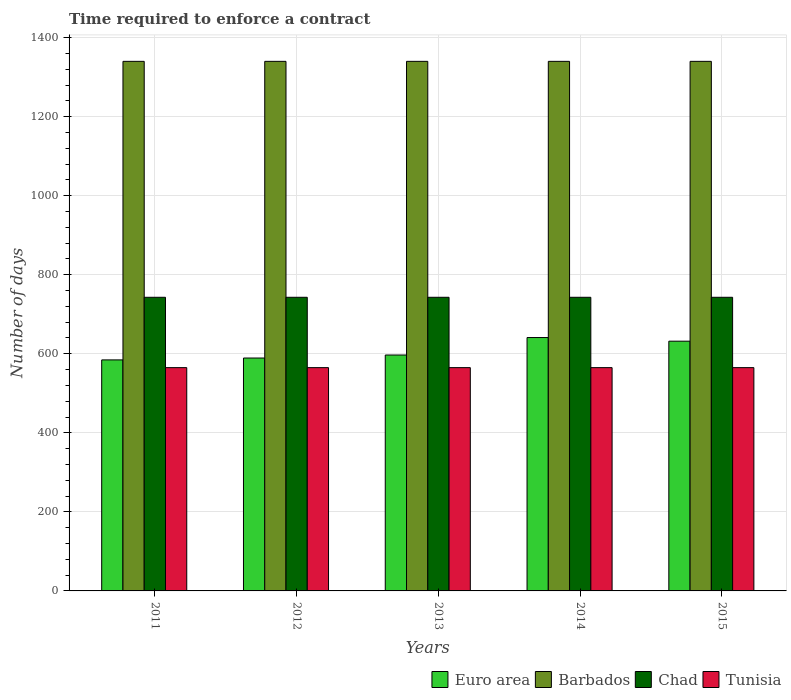How many different coloured bars are there?
Make the answer very short. 4. Are the number of bars per tick equal to the number of legend labels?
Your answer should be compact. Yes. What is the label of the 5th group of bars from the left?
Your answer should be very brief. 2015. What is the number of days required to enforce a contract in Tunisia in 2014?
Keep it short and to the point. 565. Across all years, what is the maximum number of days required to enforce a contract in Barbados?
Offer a terse response. 1340. Across all years, what is the minimum number of days required to enforce a contract in Tunisia?
Your answer should be compact. 565. What is the total number of days required to enforce a contract in Chad in the graph?
Offer a very short reply. 3715. What is the difference between the number of days required to enforce a contract in Barbados in 2015 and the number of days required to enforce a contract in Euro area in 2013?
Ensure brevity in your answer.  743.05. What is the average number of days required to enforce a contract in Chad per year?
Offer a terse response. 743. In the year 2013, what is the difference between the number of days required to enforce a contract in Tunisia and number of days required to enforce a contract in Barbados?
Give a very brief answer. -775. What is the ratio of the number of days required to enforce a contract in Euro area in 2013 to that in 2014?
Your answer should be very brief. 0.93. What is the difference between the highest and the lowest number of days required to enforce a contract in Chad?
Provide a succinct answer. 0. Is it the case that in every year, the sum of the number of days required to enforce a contract in Tunisia and number of days required to enforce a contract in Barbados is greater than the sum of number of days required to enforce a contract in Chad and number of days required to enforce a contract in Euro area?
Provide a short and direct response. No. What does the 2nd bar from the left in 2011 represents?
Provide a succinct answer. Barbados. What does the 2nd bar from the right in 2014 represents?
Ensure brevity in your answer.  Chad. Is it the case that in every year, the sum of the number of days required to enforce a contract in Tunisia and number of days required to enforce a contract in Chad is greater than the number of days required to enforce a contract in Euro area?
Provide a succinct answer. Yes. How many bars are there?
Your answer should be very brief. 20. Are all the bars in the graph horizontal?
Keep it short and to the point. No. What is the difference between two consecutive major ticks on the Y-axis?
Your answer should be very brief. 200. Does the graph contain any zero values?
Keep it short and to the point. No. Does the graph contain grids?
Ensure brevity in your answer.  Yes. How many legend labels are there?
Keep it short and to the point. 4. How are the legend labels stacked?
Give a very brief answer. Horizontal. What is the title of the graph?
Your answer should be very brief. Time required to enforce a contract. Does "Guinea-Bissau" appear as one of the legend labels in the graph?
Keep it short and to the point. No. What is the label or title of the Y-axis?
Give a very brief answer. Number of days. What is the Number of days of Euro area in 2011?
Ensure brevity in your answer.  584.58. What is the Number of days of Barbados in 2011?
Your answer should be compact. 1340. What is the Number of days of Chad in 2011?
Make the answer very short. 743. What is the Number of days in Tunisia in 2011?
Your answer should be very brief. 565. What is the Number of days in Euro area in 2012?
Ensure brevity in your answer.  589.32. What is the Number of days in Barbados in 2012?
Give a very brief answer. 1340. What is the Number of days in Chad in 2012?
Make the answer very short. 743. What is the Number of days in Tunisia in 2012?
Give a very brief answer. 565. What is the Number of days in Euro area in 2013?
Your response must be concise. 596.95. What is the Number of days in Barbados in 2013?
Your answer should be very brief. 1340. What is the Number of days in Chad in 2013?
Make the answer very short. 743. What is the Number of days of Tunisia in 2013?
Make the answer very short. 565. What is the Number of days of Euro area in 2014?
Make the answer very short. 641.16. What is the Number of days in Barbados in 2014?
Make the answer very short. 1340. What is the Number of days in Chad in 2014?
Keep it short and to the point. 743. What is the Number of days in Tunisia in 2014?
Your answer should be compact. 565. What is the Number of days in Euro area in 2015?
Make the answer very short. 631.95. What is the Number of days of Barbados in 2015?
Give a very brief answer. 1340. What is the Number of days in Chad in 2015?
Your answer should be compact. 743. What is the Number of days of Tunisia in 2015?
Your answer should be compact. 565. Across all years, what is the maximum Number of days in Euro area?
Give a very brief answer. 641.16. Across all years, what is the maximum Number of days of Barbados?
Offer a terse response. 1340. Across all years, what is the maximum Number of days in Chad?
Provide a short and direct response. 743. Across all years, what is the maximum Number of days of Tunisia?
Your response must be concise. 565. Across all years, what is the minimum Number of days in Euro area?
Offer a terse response. 584.58. Across all years, what is the minimum Number of days of Barbados?
Provide a short and direct response. 1340. Across all years, what is the minimum Number of days of Chad?
Provide a succinct answer. 743. Across all years, what is the minimum Number of days of Tunisia?
Offer a terse response. 565. What is the total Number of days of Euro area in the graph?
Your response must be concise. 3043.95. What is the total Number of days in Barbados in the graph?
Keep it short and to the point. 6700. What is the total Number of days in Chad in the graph?
Your response must be concise. 3715. What is the total Number of days in Tunisia in the graph?
Provide a short and direct response. 2825. What is the difference between the Number of days of Euro area in 2011 and that in 2012?
Your answer should be compact. -4.74. What is the difference between the Number of days in Chad in 2011 and that in 2012?
Offer a very short reply. 0. What is the difference between the Number of days in Euro area in 2011 and that in 2013?
Provide a short and direct response. -12.37. What is the difference between the Number of days in Barbados in 2011 and that in 2013?
Ensure brevity in your answer.  0. What is the difference between the Number of days of Tunisia in 2011 and that in 2013?
Provide a short and direct response. 0. What is the difference between the Number of days in Euro area in 2011 and that in 2014?
Make the answer very short. -56.58. What is the difference between the Number of days of Chad in 2011 and that in 2014?
Provide a short and direct response. 0. What is the difference between the Number of days in Euro area in 2011 and that in 2015?
Your response must be concise. -47.37. What is the difference between the Number of days in Euro area in 2012 and that in 2013?
Your answer should be compact. -7.63. What is the difference between the Number of days of Barbados in 2012 and that in 2013?
Ensure brevity in your answer.  0. What is the difference between the Number of days of Chad in 2012 and that in 2013?
Provide a short and direct response. 0. What is the difference between the Number of days in Euro area in 2012 and that in 2014?
Your response must be concise. -51.84. What is the difference between the Number of days of Barbados in 2012 and that in 2014?
Offer a very short reply. 0. What is the difference between the Number of days of Euro area in 2012 and that in 2015?
Give a very brief answer. -42.63. What is the difference between the Number of days of Barbados in 2012 and that in 2015?
Keep it short and to the point. 0. What is the difference between the Number of days of Euro area in 2013 and that in 2014?
Give a very brief answer. -44.21. What is the difference between the Number of days of Chad in 2013 and that in 2014?
Your answer should be very brief. 0. What is the difference between the Number of days in Tunisia in 2013 and that in 2014?
Offer a terse response. 0. What is the difference between the Number of days in Euro area in 2013 and that in 2015?
Your answer should be very brief. -35. What is the difference between the Number of days in Barbados in 2013 and that in 2015?
Offer a very short reply. 0. What is the difference between the Number of days in Chad in 2013 and that in 2015?
Make the answer very short. 0. What is the difference between the Number of days in Euro area in 2014 and that in 2015?
Ensure brevity in your answer.  9.21. What is the difference between the Number of days in Barbados in 2014 and that in 2015?
Offer a very short reply. 0. What is the difference between the Number of days in Chad in 2014 and that in 2015?
Make the answer very short. 0. What is the difference between the Number of days of Tunisia in 2014 and that in 2015?
Provide a succinct answer. 0. What is the difference between the Number of days in Euro area in 2011 and the Number of days in Barbados in 2012?
Provide a succinct answer. -755.42. What is the difference between the Number of days in Euro area in 2011 and the Number of days in Chad in 2012?
Provide a short and direct response. -158.42. What is the difference between the Number of days in Euro area in 2011 and the Number of days in Tunisia in 2012?
Provide a succinct answer. 19.58. What is the difference between the Number of days in Barbados in 2011 and the Number of days in Chad in 2012?
Keep it short and to the point. 597. What is the difference between the Number of days in Barbados in 2011 and the Number of days in Tunisia in 2012?
Provide a succinct answer. 775. What is the difference between the Number of days in Chad in 2011 and the Number of days in Tunisia in 2012?
Give a very brief answer. 178. What is the difference between the Number of days of Euro area in 2011 and the Number of days of Barbados in 2013?
Provide a short and direct response. -755.42. What is the difference between the Number of days of Euro area in 2011 and the Number of days of Chad in 2013?
Your answer should be very brief. -158.42. What is the difference between the Number of days of Euro area in 2011 and the Number of days of Tunisia in 2013?
Keep it short and to the point. 19.58. What is the difference between the Number of days of Barbados in 2011 and the Number of days of Chad in 2013?
Give a very brief answer. 597. What is the difference between the Number of days of Barbados in 2011 and the Number of days of Tunisia in 2013?
Make the answer very short. 775. What is the difference between the Number of days in Chad in 2011 and the Number of days in Tunisia in 2013?
Give a very brief answer. 178. What is the difference between the Number of days in Euro area in 2011 and the Number of days in Barbados in 2014?
Keep it short and to the point. -755.42. What is the difference between the Number of days of Euro area in 2011 and the Number of days of Chad in 2014?
Offer a terse response. -158.42. What is the difference between the Number of days of Euro area in 2011 and the Number of days of Tunisia in 2014?
Your answer should be compact. 19.58. What is the difference between the Number of days in Barbados in 2011 and the Number of days in Chad in 2014?
Ensure brevity in your answer.  597. What is the difference between the Number of days of Barbados in 2011 and the Number of days of Tunisia in 2014?
Your answer should be very brief. 775. What is the difference between the Number of days of Chad in 2011 and the Number of days of Tunisia in 2014?
Give a very brief answer. 178. What is the difference between the Number of days of Euro area in 2011 and the Number of days of Barbados in 2015?
Your answer should be compact. -755.42. What is the difference between the Number of days of Euro area in 2011 and the Number of days of Chad in 2015?
Make the answer very short. -158.42. What is the difference between the Number of days in Euro area in 2011 and the Number of days in Tunisia in 2015?
Offer a very short reply. 19.58. What is the difference between the Number of days in Barbados in 2011 and the Number of days in Chad in 2015?
Your answer should be very brief. 597. What is the difference between the Number of days of Barbados in 2011 and the Number of days of Tunisia in 2015?
Make the answer very short. 775. What is the difference between the Number of days of Chad in 2011 and the Number of days of Tunisia in 2015?
Ensure brevity in your answer.  178. What is the difference between the Number of days of Euro area in 2012 and the Number of days of Barbados in 2013?
Give a very brief answer. -750.68. What is the difference between the Number of days of Euro area in 2012 and the Number of days of Chad in 2013?
Give a very brief answer. -153.68. What is the difference between the Number of days of Euro area in 2012 and the Number of days of Tunisia in 2013?
Your response must be concise. 24.32. What is the difference between the Number of days in Barbados in 2012 and the Number of days in Chad in 2013?
Offer a terse response. 597. What is the difference between the Number of days of Barbados in 2012 and the Number of days of Tunisia in 2013?
Offer a terse response. 775. What is the difference between the Number of days in Chad in 2012 and the Number of days in Tunisia in 2013?
Give a very brief answer. 178. What is the difference between the Number of days in Euro area in 2012 and the Number of days in Barbados in 2014?
Provide a short and direct response. -750.68. What is the difference between the Number of days of Euro area in 2012 and the Number of days of Chad in 2014?
Make the answer very short. -153.68. What is the difference between the Number of days in Euro area in 2012 and the Number of days in Tunisia in 2014?
Offer a terse response. 24.32. What is the difference between the Number of days of Barbados in 2012 and the Number of days of Chad in 2014?
Provide a succinct answer. 597. What is the difference between the Number of days in Barbados in 2012 and the Number of days in Tunisia in 2014?
Keep it short and to the point. 775. What is the difference between the Number of days in Chad in 2012 and the Number of days in Tunisia in 2014?
Your answer should be compact. 178. What is the difference between the Number of days in Euro area in 2012 and the Number of days in Barbados in 2015?
Your answer should be compact. -750.68. What is the difference between the Number of days of Euro area in 2012 and the Number of days of Chad in 2015?
Provide a short and direct response. -153.68. What is the difference between the Number of days in Euro area in 2012 and the Number of days in Tunisia in 2015?
Make the answer very short. 24.32. What is the difference between the Number of days of Barbados in 2012 and the Number of days of Chad in 2015?
Provide a succinct answer. 597. What is the difference between the Number of days in Barbados in 2012 and the Number of days in Tunisia in 2015?
Ensure brevity in your answer.  775. What is the difference between the Number of days in Chad in 2012 and the Number of days in Tunisia in 2015?
Ensure brevity in your answer.  178. What is the difference between the Number of days in Euro area in 2013 and the Number of days in Barbados in 2014?
Make the answer very short. -743.05. What is the difference between the Number of days of Euro area in 2013 and the Number of days of Chad in 2014?
Offer a very short reply. -146.05. What is the difference between the Number of days of Euro area in 2013 and the Number of days of Tunisia in 2014?
Make the answer very short. 31.95. What is the difference between the Number of days in Barbados in 2013 and the Number of days in Chad in 2014?
Your answer should be very brief. 597. What is the difference between the Number of days of Barbados in 2013 and the Number of days of Tunisia in 2014?
Offer a very short reply. 775. What is the difference between the Number of days of Chad in 2013 and the Number of days of Tunisia in 2014?
Your response must be concise. 178. What is the difference between the Number of days in Euro area in 2013 and the Number of days in Barbados in 2015?
Provide a succinct answer. -743.05. What is the difference between the Number of days of Euro area in 2013 and the Number of days of Chad in 2015?
Provide a short and direct response. -146.05. What is the difference between the Number of days in Euro area in 2013 and the Number of days in Tunisia in 2015?
Make the answer very short. 31.95. What is the difference between the Number of days in Barbados in 2013 and the Number of days in Chad in 2015?
Keep it short and to the point. 597. What is the difference between the Number of days in Barbados in 2013 and the Number of days in Tunisia in 2015?
Provide a short and direct response. 775. What is the difference between the Number of days of Chad in 2013 and the Number of days of Tunisia in 2015?
Offer a very short reply. 178. What is the difference between the Number of days of Euro area in 2014 and the Number of days of Barbados in 2015?
Provide a succinct answer. -698.84. What is the difference between the Number of days in Euro area in 2014 and the Number of days in Chad in 2015?
Provide a succinct answer. -101.84. What is the difference between the Number of days in Euro area in 2014 and the Number of days in Tunisia in 2015?
Your response must be concise. 76.16. What is the difference between the Number of days in Barbados in 2014 and the Number of days in Chad in 2015?
Your answer should be compact. 597. What is the difference between the Number of days in Barbados in 2014 and the Number of days in Tunisia in 2015?
Make the answer very short. 775. What is the difference between the Number of days in Chad in 2014 and the Number of days in Tunisia in 2015?
Make the answer very short. 178. What is the average Number of days of Euro area per year?
Give a very brief answer. 608.79. What is the average Number of days in Barbados per year?
Provide a succinct answer. 1340. What is the average Number of days in Chad per year?
Keep it short and to the point. 743. What is the average Number of days of Tunisia per year?
Offer a terse response. 565. In the year 2011, what is the difference between the Number of days in Euro area and Number of days in Barbados?
Provide a succinct answer. -755.42. In the year 2011, what is the difference between the Number of days in Euro area and Number of days in Chad?
Provide a short and direct response. -158.42. In the year 2011, what is the difference between the Number of days of Euro area and Number of days of Tunisia?
Your answer should be very brief. 19.58. In the year 2011, what is the difference between the Number of days in Barbados and Number of days in Chad?
Offer a terse response. 597. In the year 2011, what is the difference between the Number of days in Barbados and Number of days in Tunisia?
Offer a very short reply. 775. In the year 2011, what is the difference between the Number of days of Chad and Number of days of Tunisia?
Provide a short and direct response. 178. In the year 2012, what is the difference between the Number of days in Euro area and Number of days in Barbados?
Your response must be concise. -750.68. In the year 2012, what is the difference between the Number of days of Euro area and Number of days of Chad?
Make the answer very short. -153.68. In the year 2012, what is the difference between the Number of days in Euro area and Number of days in Tunisia?
Keep it short and to the point. 24.32. In the year 2012, what is the difference between the Number of days in Barbados and Number of days in Chad?
Your answer should be compact. 597. In the year 2012, what is the difference between the Number of days of Barbados and Number of days of Tunisia?
Offer a terse response. 775. In the year 2012, what is the difference between the Number of days in Chad and Number of days in Tunisia?
Provide a short and direct response. 178. In the year 2013, what is the difference between the Number of days of Euro area and Number of days of Barbados?
Ensure brevity in your answer.  -743.05. In the year 2013, what is the difference between the Number of days of Euro area and Number of days of Chad?
Offer a terse response. -146.05. In the year 2013, what is the difference between the Number of days in Euro area and Number of days in Tunisia?
Your answer should be compact. 31.95. In the year 2013, what is the difference between the Number of days in Barbados and Number of days in Chad?
Your response must be concise. 597. In the year 2013, what is the difference between the Number of days in Barbados and Number of days in Tunisia?
Keep it short and to the point. 775. In the year 2013, what is the difference between the Number of days in Chad and Number of days in Tunisia?
Make the answer very short. 178. In the year 2014, what is the difference between the Number of days of Euro area and Number of days of Barbados?
Provide a short and direct response. -698.84. In the year 2014, what is the difference between the Number of days of Euro area and Number of days of Chad?
Your answer should be compact. -101.84. In the year 2014, what is the difference between the Number of days of Euro area and Number of days of Tunisia?
Your response must be concise. 76.16. In the year 2014, what is the difference between the Number of days of Barbados and Number of days of Chad?
Give a very brief answer. 597. In the year 2014, what is the difference between the Number of days of Barbados and Number of days of Tunisia?
Ensure brevity in your answer.  775. In the year 2014, what is the difference between the Number of days of Chad and Number of days of Tunisia?
Your response must be concise. 178. In the year 2015, what is the difference between the Number of days of Euro area and Number of days of Barbados?
Provide a short and direct response. -708.05. In the year 2015, what is the difference between the Number of days of Euro area and Number of days of Chad?
Ensure brevity in your answer.  -111.05. In the year 2015, what is the difference between the Number of days in Euro area and Number of days in Tunisia?
Make the answer very short. 66.95. In the year 2015, what is the difference between the Number of days in Barbados and Number of days in Chad?
Provide a short and direct response. 597. In the year 2015, what is the difference between the Number of days in Barbados and Number of days in Tunisia?
Ensure brevity in your answer.  775. In the year 2015, what is the difference between the Number of days in Chad and Number of days in Tunisia?
Your response must be concise. 178. What is the ratio of the Number of days in Euro area in 2011 to that in 2012?
Make the answer very short. 0.99. What is the ratio of the Number of days in Euro area in 2011 to that in 2013?
Make the answer very short. 0.98. What is the ratio of the Number of days of Chad in 2011 to that in 2013?
Provide a succinct answer. 1. What is the ratio of the Number of days of Euro area in 2011 to that in 2014?
Your answer should be very brief. 0.91. What is the ratio of the Number of days of Euro area in 2011 to that in 2015?
Ensure brevity in your answer.  0.93. What is the ratio of the Number of days of Barbados in 2011 to that in 2015?
Your response must be concise. 1. What is the ratio of the Number of days in Chad in 2011 to that in 2015?
Offer a terse response. 1. What is the ratio of the Number of days of Euro area in 2012 to that in 2013?
Ensure brevity in your answer.  0.99. What is the ratio of the Number of days in Chad in 2012 to that in 2013?
Your answer should be compact. 1. What is the ratio of the Number of days in Euro area in 2012 to that in 2014?
Offer a terse response. 0.92. What is the ratio of the Number of days of Barbados in 2012 to that in 2014?
Keep it short and to the point. 1. What is the ratio of the Number of days of Chad in 2012 to that in 2014?
Provide a succinct answer. 1. What is the ratio of the Number of days of Euro area in 2012 to that in 2015?
Provide a short and direct response. 0.93. What is the ratio of the Number of days in Tunisia in 2012 to that in 2015?
Offer a terse response. 1. What is the ratio of the Number of days of Barbados in 2013 to that in 2014?
Provide a succinct answer. 1. What is the ratio of the Number of days of Euro area in 2013 to that in 2015?
Make the answer very short. 0.94. What is the ratio of the Number of days in Chad in 2013 to that in 2015?
Your answer should be compact. 1. What is the ratio of the Number of days of Euro area in 2014 to that in 2015?
Your response must be concise. 1.01. What is the ratio of the Number of days in Tunisia in 2014 to that in 2015?
Give a very brief answer. 1. What is the difference between the highest and the second highest Number of days of Euro area?
Provide a succinct answer. 9.21. What is the difference between the highest and the second highest Number of days of Barbados?
Your response must be concise. 0. What is the difference between the highest and the second highest Number of days of Tunisia?
Offer a terse response. 0. What is the difference between the highest and the lowest Number of days in Euro area?
Give a very brief answer. 56.58. What is the difference between the highest and the lowest Number of days of Tunisia?
Your answer should be very brief. 0. 